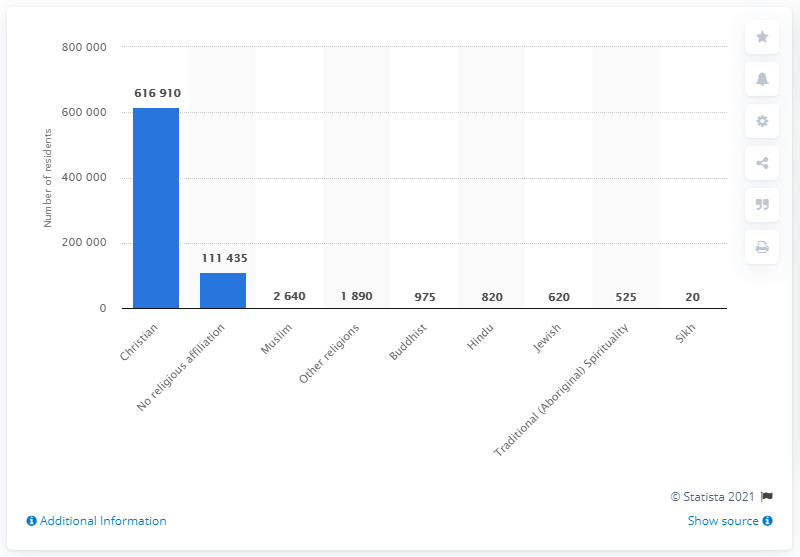Identify some key points in this picture. In 2011, approximately 600,000 Canadian citizens and permanent/non-permanent residents of New Brunswick identified as Christian. 